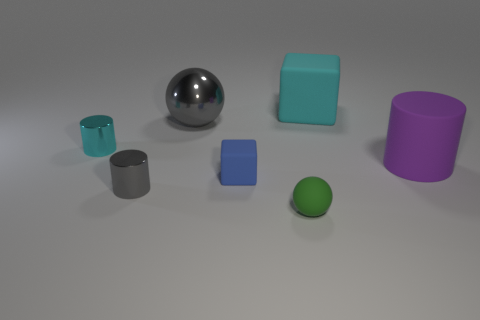Is there a big gray shiny thing that has the same shape as the small green object?
Offer a terse response. Yes. Are there an equal number of big matte blocks that are on the left side of the tiny green matte object and large blue matte spheres?
Offer a very short reply. Yes. There is a blue rubber thing; is its size the same as the cyan thing that is to the left of the green matte object?
Keep it short and to the point. Yes. What number of gray objects have the same material as the big block?
Your response must be concise. 0. Do the gray shiny cylinder and the green matte sphere have the same size?
Give a very brief answer. Yes. Is there any other thing that has the same color as the big metallic ball?
Offer a terse response. Yes. There is a large thing that is both on the right side of the rubber ball and behind the tiny cyan metal object; what shape is it?
Offer a very short reply. Cube. What is the size of the cyan thing to the left of the tiny blue cube?
Make the answer very short. Small. What number of blue blocks are to the right of the rubber cube that is to the right of the small matte object that is behind the small gray object?
Ensure brevity in your answer.  0. There is a large shiny ball; are there any cyan rubber cubes right of it?
Offer a terse response. Yes. 